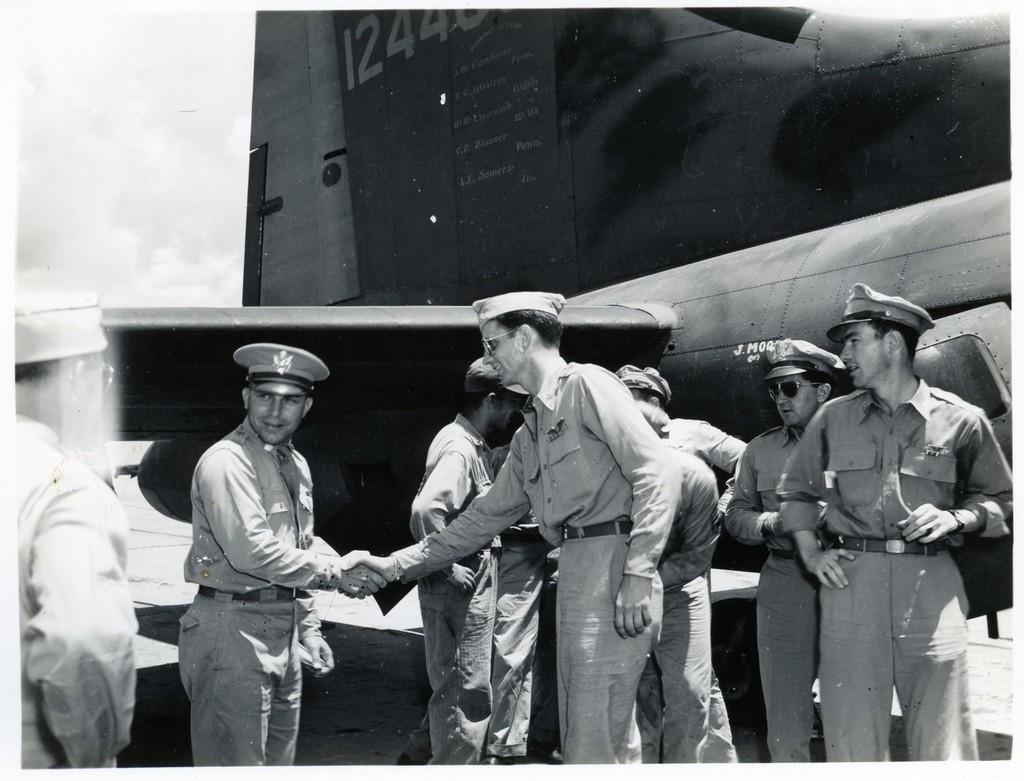In one or two sentences, can you explain what this image depicts? In this image I can see group of people standing, background I can see an aircraft and the sky and the image is in black and white. 